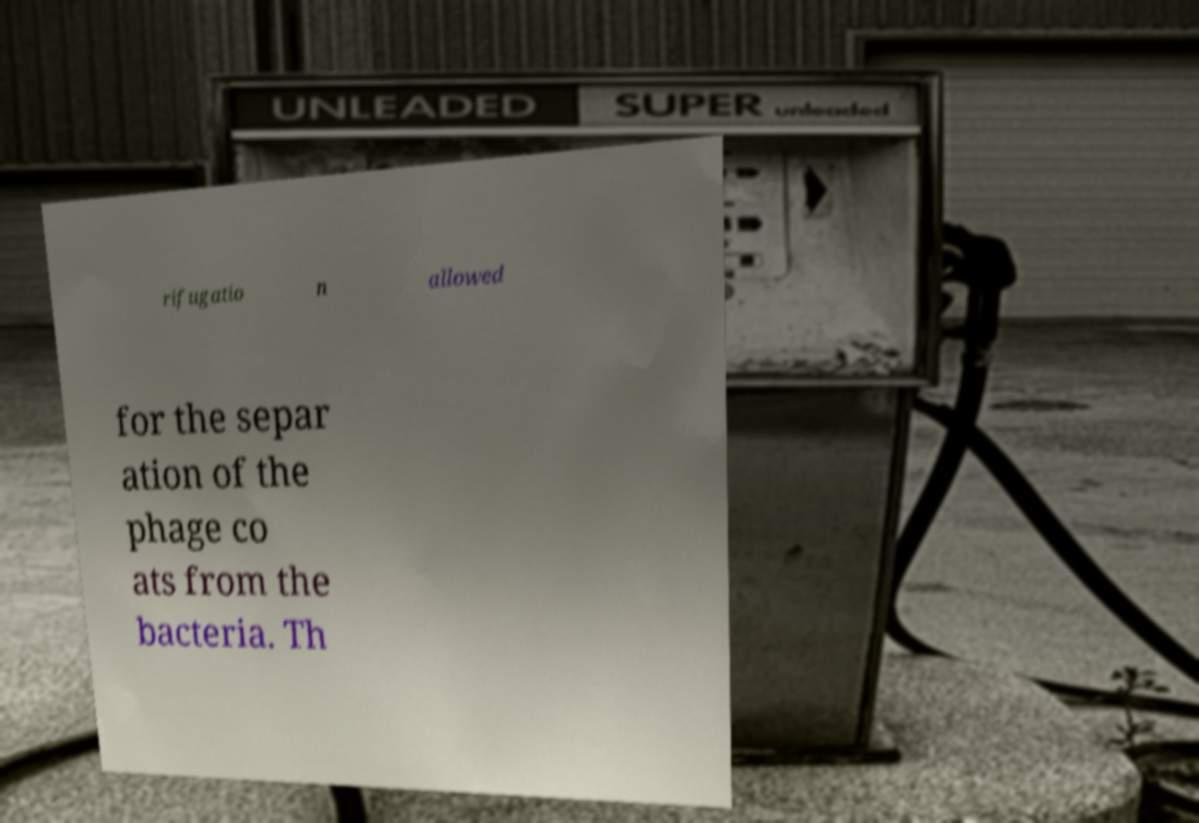Please identify and transcribe the text found in this image. rifugatio n allowed for the separ ation of the phage co ats from the bacteria. Th 